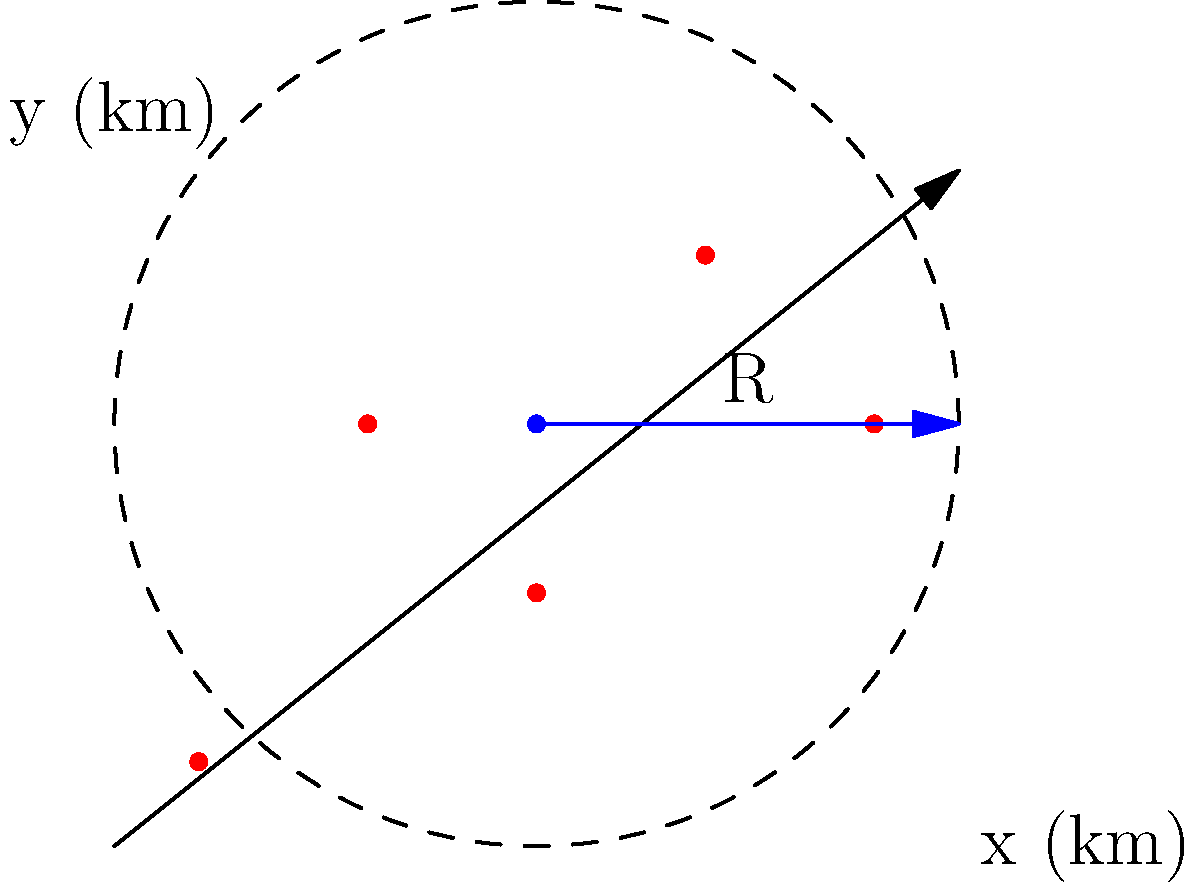Based on the map of protest locations where pamphlets were distributed, calculate the minimum radius $R$ (in km) of the circular distribution area that encompasses all protest points. Round your answer to one decimal place. To find the minimum radius that encompasses all protest points, we need to:

1. Identify the center of the circle:
   The center appears to be at coordinates (2, 2).

2. Calculate the distance from the center to each point:
   We can use the distance formula: $d = \sqrt{(x_2-x_1)^2 + (y_2-y_1)^2}$

   For each point (x, y):
   a. (0, 0): $d = \sqrt{(0-2)^2 + (0-2)^2} = \sqrt{8} \approx 2.83$ km
   b. (1, 2): $d = \sqrt{(1-2)^2 + (2-2)^2} = 1$ km
   c. (2, 1): $d = \sqrt{(2-2)^2 + (1-2)^2} = 1$ km
   d. (3, 3): $d = \sqrt{(3-2)^2 + (3-2)^2} = \sqrt{2} \approx 1.41$ km
   e. (4, 2): $d = \sqrt{(4-2)^2 + (2-2)^2} = 2$ km

3. Find the maximum distance:
   The maximum distance is approximately 2.83 km (for the point at (0, 0)).

4. Round to one decimal place:
   2.83 rounded to one decimal place is 2.8 km.

Therefore, the minimum radius $R$ that encompasses all protest points is 2.8 km.
Answer: 2.8 km 